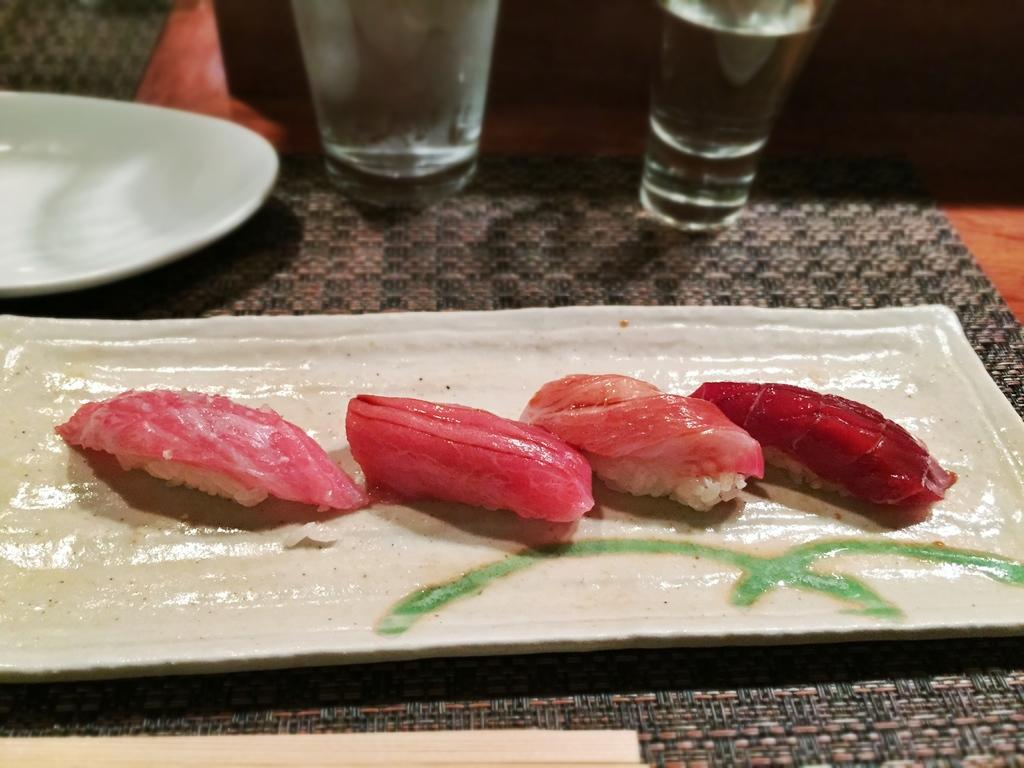What type of food items can be seen on the plate in the image? The specific type of food items is not mentioned, but there are food items on a plate in the image. How many glasses of water are visible in the image? There are two glasses of water in the image. What is the condition of the plate on the table mat? The plate on the table mat is empty. What type of joke is being told by the curve in the image? There is no curve or joke present in the image. What is the back of the image showing? The provided facts do not mention anything about the back of the image, so we cannot answer this question. 